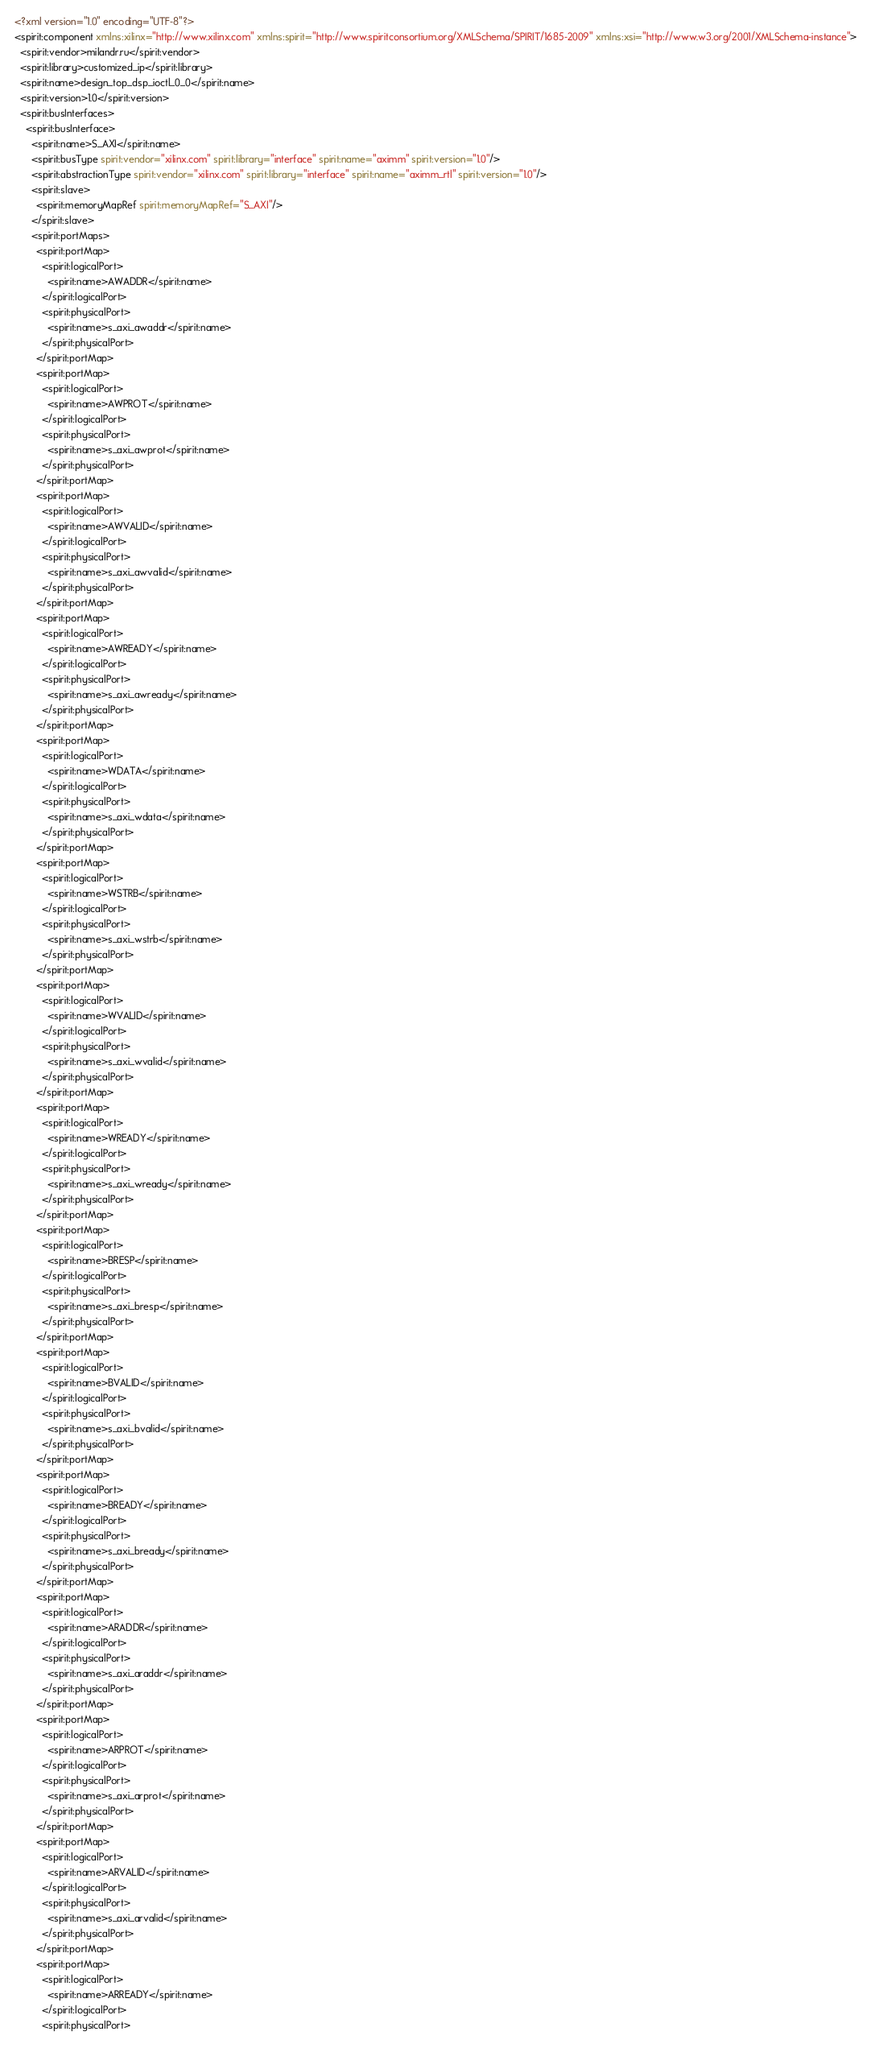Convert code to text. <code><loc_0><loc_0><loc_500><loc_500><_XML_><?xml version="1.0" encoding="UTF-8"?>
<spirit:component xmlns:xilinx="http://www.xilinx.com" xmlns:spirit="http://www.spiritconsortium.org/XMLSchema/SPIRIT/1685-2009" xmlns:xsi="http://www.w3.org/2001/XMLSchema-instance">
  <spirit:vendor>milandr.ru</spirit:vendor>
  <spirit:library>customized_ip</spirit:library>
  <spirit:name>design_top_dsp_ioctl_0_0</spirit:name>
  <spirit:version>1.0</spirit:version>
  <spirit:busInterfaces>
    <spirit:busInterface>
      <spirit:name>S_AXI</spirit:name>
      <spirit:busType spirit:vendor="xilinx.com" spirit:library="interface" spirit:name="aximm" spirit:version="1.0"/>
      <spirit:abstractionType spirit:vendor="xilinx.com" spirit:library="interface" spirit:name="aximm_rtl" spirit:version="1.0"/>
      <spirit:slave>
        <spirit:memoryMapRef spirit:memoryMapRef="S_AXI"/>
      </spirit:slave>
      <spirit:portMaps>
        <spirit:portMap>
          <spirit:logicalPort>
            <spirit:name>AWADDR</spirit:name>
          </spirit:logicalPort>
          <spirit:physicalPort>
            <spirit:name>s_axi_awaddr</spirit:name>
          </spirit:physicalPort>
        </spirit:portMap>
        <spirit:portMap>
          <spirit:logicalPort>
            <spirit:name>AWPROT</spirit:name>
          </spirit:logicalPort>
          <spirit:physicalPort>
            <spirit:name>s_axi_awprot</spirit:name>
          </spirit:physicalPort>
        </spirit:portMap>
        <spirit:portMap>
          <spirit:logicalPort>
            <spirit:name>AWVALID</spirit:name>
          </spirit:logicalPort>
          <spirit:physicalPort>
            <spirit:name>s_axi_awvalid</spirit:name>
          </spirit:physicalPort>
        </spirit:portMap>
        <spirit:portMap>
          <spirit:logicalPort>
            <spirit:name>AWREADY</spirit:name>
          </spirit:logicalPort>
          <spirit:physicalPort>
            <spirit:name>s_axi_awready</spirit:name>
          </spirit:physicalPort>
        </spirit:portMap>
        <spirit:portMap>
          <spirit:logicalPort>
            <spirit:name>WDATA</spirit:name>
          </spirit:logicalPort>
          <spirit:physicalPort>
            <spirit:name>s_axi_wdata</spirit:name>
          </spirit:physicalPort>
        </spirit:portMap>
        <spirit:portMap>
          <spirit:logicalPort>
            <spirit:name>WSTRB</spirit:name>
          </spirit:logicalPort>
          <spirit:physicalPort>
            <spirit:name>s_axi_wstrb</spirit:name>
          </spirit:physicalPort>
        </spirit:portMap>
        <spirit:portMap>
          <spirit:logicalPort>
            <spirit:name>WVALID</spirit:name>
          </spirit:logicalPort>
          <spirit:physicalPort>
            <spirit:name>s_axi_wvalid</spirit:name>
          </spirit:physicalPort>
        </spirit:portMap>
        <spirit:portMap>
          <spirit:logicalPort>
            <spirit:name>WREADY</spirit:name>
          </spirit:logicalPort>
          <spirit:physicalPort>
            <spirit:name>s_axi_wready</spirit:name>
          </spirit:physicalPort>
        </spirit:portMap>
        <spirit:portMap>
          <spirit:logicalPort>
            <spirit:name>BRESP</spirit:name>
          </spirit:logicalPort>
          <spirit:physicalPort>
            <spirit:name>s_axi_bresp</spirit:name>
          </spirit:physicalPort>
        </spirit:portMap>
        <spirit:portMap>
          <spirit:logicalPort>
            <spirit:name>BVALID</spirit:name>
          </spirit:logicalPort>
          <spirit:physicalPort>
            <spirit:name>s_axi_bvalid</spirit:name>
          </spirit:physicalPort>
        </spirit:portMap>
        <spirit:portMap>
          <spirit:logicalPort>
            <spirit:name>BREADY</spirit:name>
          </spirit:logicalPort>
          <spirit:physicalPort>
            <spirit:name>s_axi_bready</spirit:name>
          </spirit:physicalPort>
        </spirit:portMap>
        <spirit:portMap>
          <spirit:logicalPort>
            <spirit:name>ARADDR</spirit:name>
          </spirit:logicalPort>
          <spirit:physicalPort>
            <spirit:name>s_axi_araddr</spirit:name>
          </spirit:physicalPort>
        </spirit:portMap>
        <spirit:portMap>
          <spirit:logicalPort>
            <spirit:name>ARPROT</spirit:name>
          </spirit:logicalPort>
          <spirit:physicalPort>
            <spirit:name>s_axi_arprot</spirit:name>
          </spirit:physicalPort>
        </spirit:portMap>
        <spirit:portMap>
          <spirit:logicalPort>
            <spirit:name>ARVALID</spirit:name>
          </spirit:logicalPort>
          <spirit:physicalPort>
            <spirit:name>s_axi_arvalid</spirit:name>
          </spirit:physicalPort>
        </spirit:portMap>
        <spirit:portMap>
          <spirit:logicalPort>
            <spirit:name>ARREADY</spirit:name>
          </spirit:logicalPort>
          <spirit:physicalPort></code> 